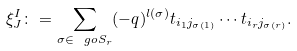Convert formula to latex. <formula><loc_0><loc_0><loc_500><loc_500>\xi ^ { I } _ { J } \colon = \sum _ { \sigma \in \ g o S _ { r } } ( - q ) ^ { l ( \sigma ) } t _ { i _ { 1 } j _ { \sigma ( 1 ) } } \cdots t _ { i _ { r } j _ { \sigma ( r ) } } .</formula> 